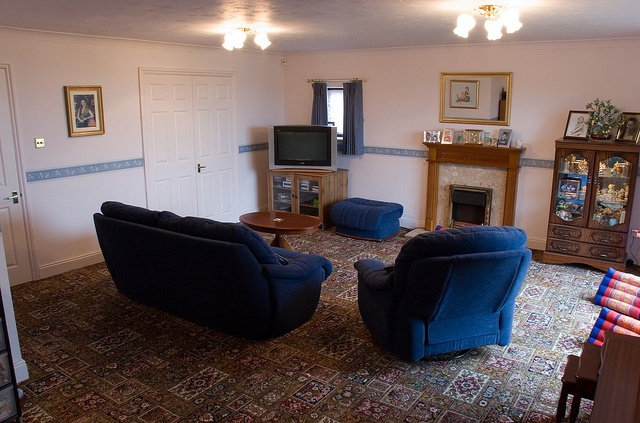Describe the objects in this image and their specific colors. I can see couch in gray, black, navy, and darkblue tones, chair in gray, black, navy, blue, and darkblue tones, tv in gray and black tones, dining table in gray, maroon, black, and brown tones, and potted plant in gray, black, and darkgreen tones in this image. 